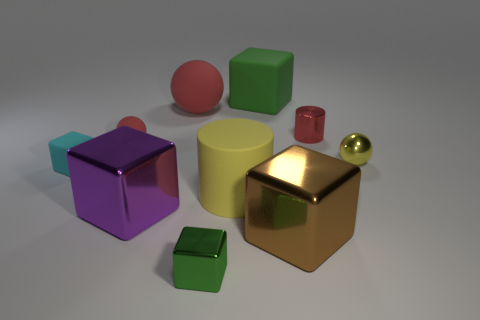Does the large matte cylinder have the same color as the big metallic block that is behind the brown object?
Your response must be concise. No. There is a green block that is the same size as the brown shiny block; what is it made of?
Offer a very short reply. Rubber. How many objects are either brown metallic cubes or tiny red things on the left side of the big green block?
Make the answer very short. 2. Do the red shiny cylinder and the matte block that is on the left side of the yellow cylinder have the same size?
Provide a succinct answer. Yes. How many cubes are either large purple things or large green objects?
Provide a succinct answer. 2. How many balls are on the left side of the yellow sphere and in front of the large matte sphere?
Offer a very short reply. 1. What number of other things are there of the same color as the tiny matte ball?
Your answer should be very brief. 2. There is a yellow object that is on the left side of the large brown metallic block; what shape is it?
Ensure brevity in your answer.  Cylinder. Is the tiny cyan thing made of the same material as the large yellow cylinder?
Provide a succinct answer. Yes. Is there anything else that has the same size as the yellow shiny thing?
Ensure brevity in your answer.  Yes. 